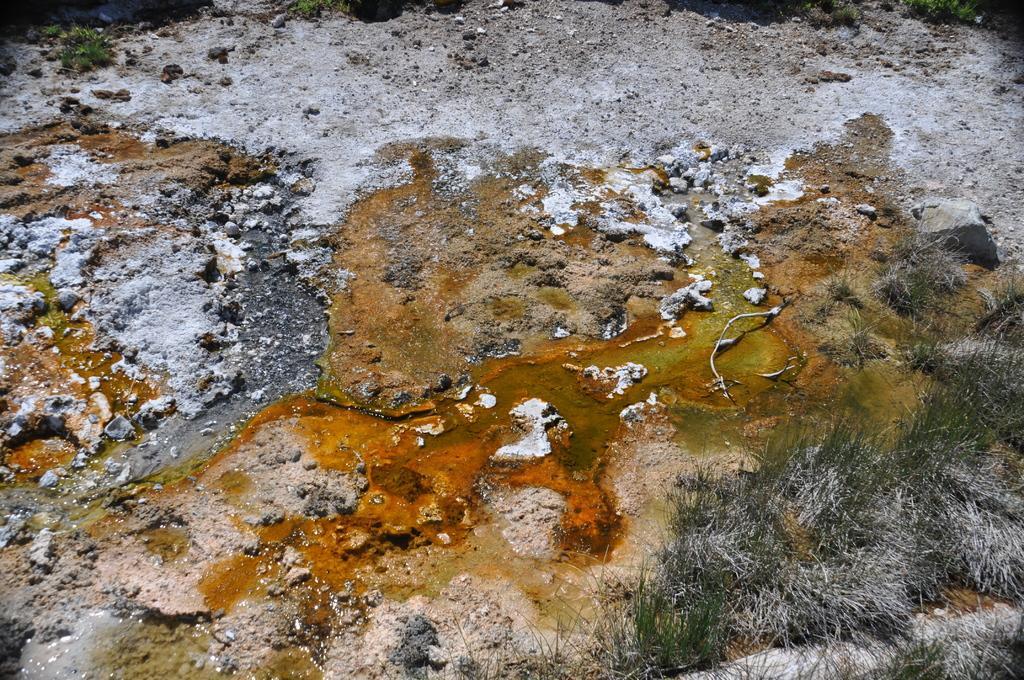Can you describe this image briefly? In this picture we can see stones, grass, algae on the ground. 